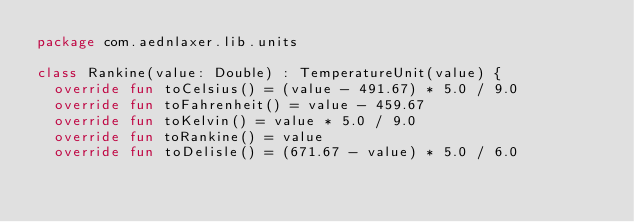<code> <loc_0><loc_0><loc_500><loc_500><_Kotlin_>package com.aednlaxer.lib.units

class Rankine(value: Double) : TemperatureUnit(value) {
  override fun toCelsius() = (value - 491.67) * 5.0 / 9.0
  override fun toFahrenheit() = value - 459.67
  override fun toKelvin() = value * 5.0 / 9.0
  override fun toRankine() = value
  override fun toDelisle() = (671.67 - value) * 5.0 / 6.0</code> 